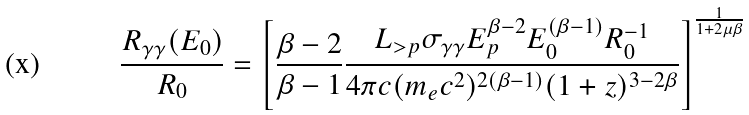<formula> <loc_0><loc_0><loc_500><loc_500>\frac { R _ { \gamma \gamma } ( E _ { 0 } ) } { R _ { 0 } } = \left [ \frac { \beta - 2 } { \beta - 1 } \frac { L _ { > p } \sigma _ { \gamma \gamma } E _ { p } ^ { \beta - 2 } E _ { 0 } ^ { ( \beta - 1 ) } R _ { 0 } ^ { - 1 } } { 4 \pi c ( m _ { e } c ^ { 2 } ) ^ { 2 ( \beta - 1 ) } ( 1 + z ) ^ { 3 - 2 \beta } } \right ] ^ { \frac { 1 } { 1 + 2 \mu \beta } }</formula> 